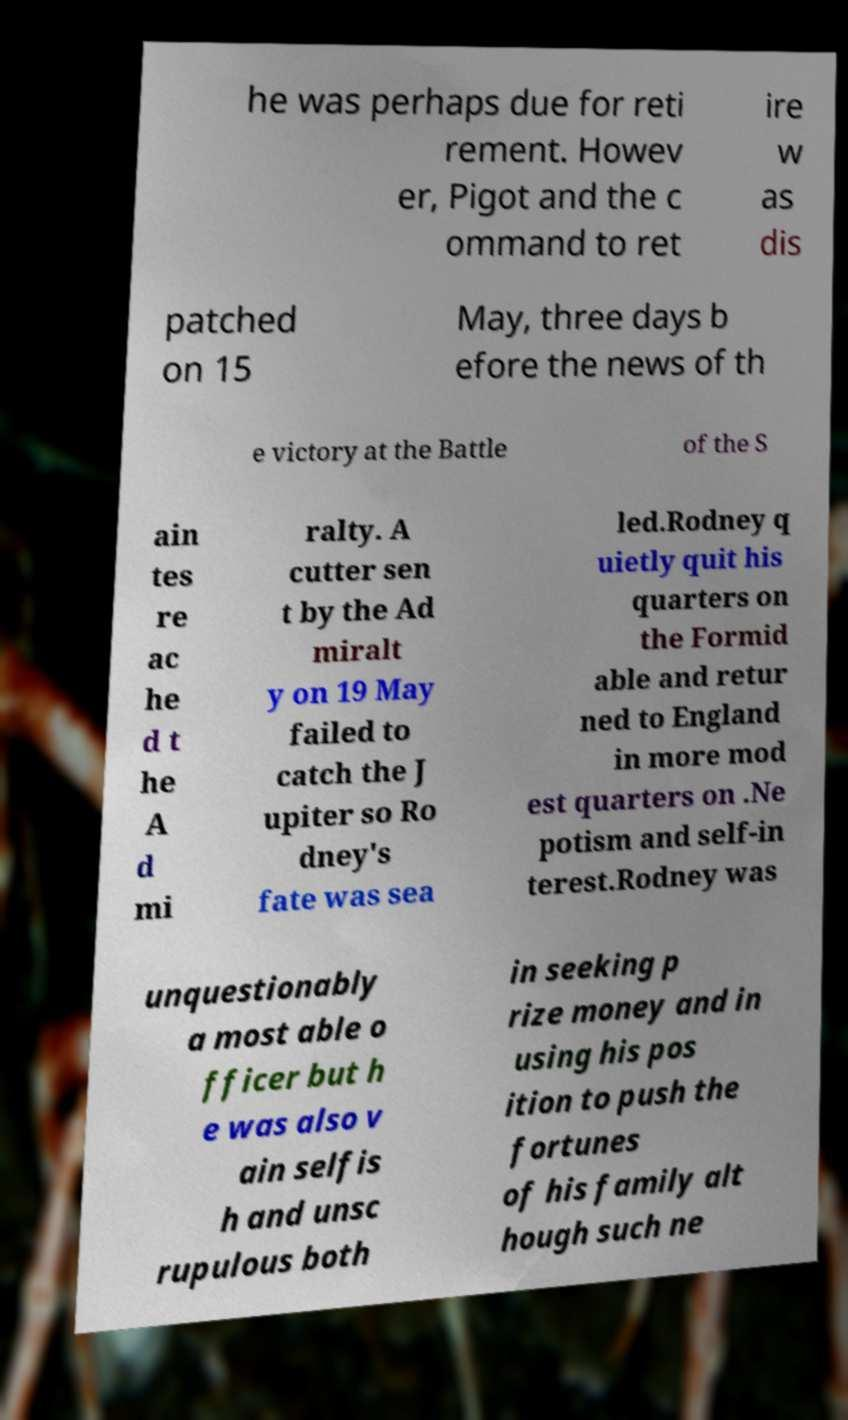There's text embedded in this image that I need extracted. Can you transcribe it verbatim? he was perhaps due for reti rement. Howev er, Pigot and the c ommand to ret ire w as dis patched on 15 May, three days b efore the news of th e victory at the Battle of the S ain tes re ac he d t he A d mi ralty. A cutter sen t by the Ad miralt y on 19 May failed to catch the J upiter so Ro dney's fate was sea led.Rodney q uietly quit his quarters on the Formid able and retur ned to England in more mod est quarters on .Ne potism and self-in terest.Rodney was unquestionably a most able o fficer but h e was also v ain selfis h and unsc rupulous both in seeking p rize money and in using his pos ition to push the fortunes of his family alt hough such ne 